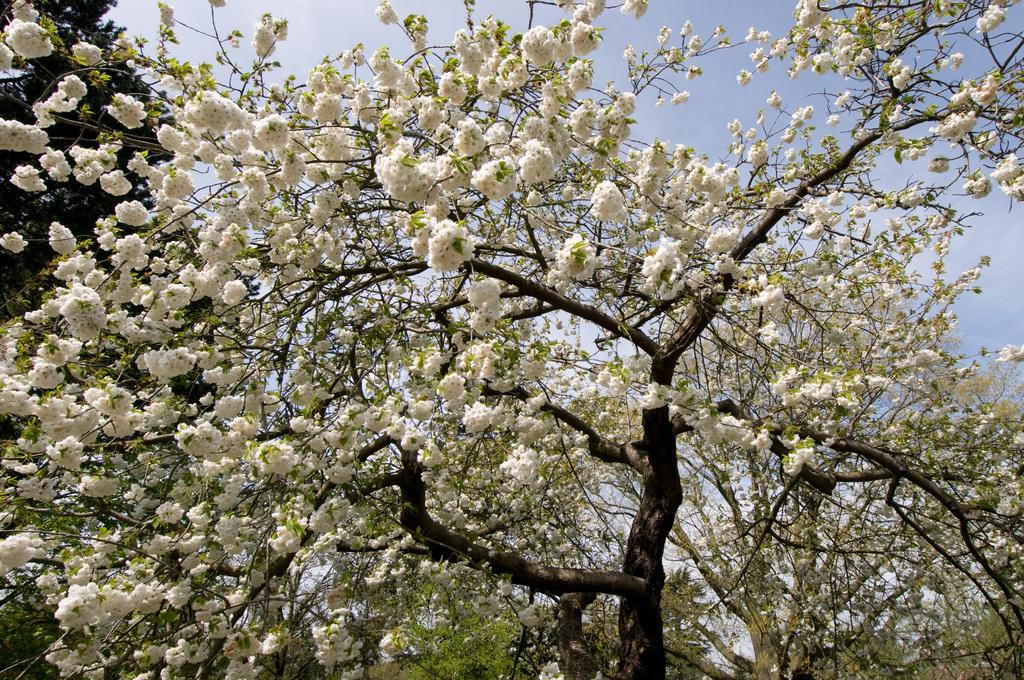What type of vegetation can be seen in the image? There are trees in the image. What color are the flowers in the image? The flowers in the image are white-colored. What can be seen in the background of the image? The sky is visible in the background of the image. What type of journey does the ray take in the image? There is no ray present in the image, so it cannot take a journey. 